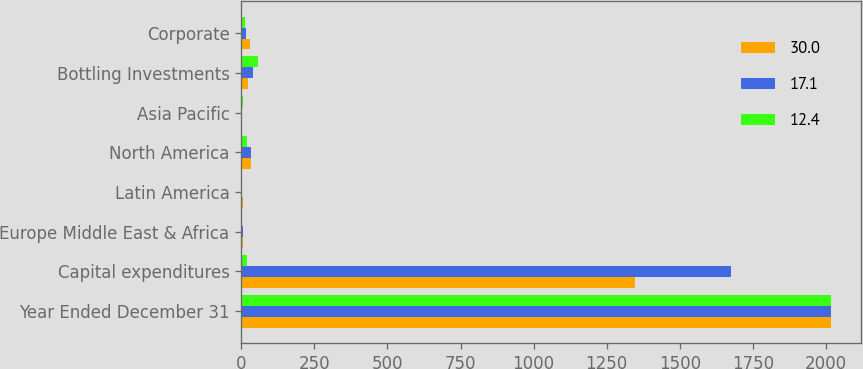Convert chart. <chart><loc_0><loc_0><loc_500><loc_500><stacked_bar_chart><ecel><fcel>Year Ended December 31<fcel>Capital expenditures<fcel>Europe Middle East & Africa<fcel>Latin America<fcel>North America<fcel>Asia Pacific<fcel>Bottling Investments<fcel>Corporate<nl><fcel>30<fcel>2018<fcel>1347<fcel>5.7<fcel>6.7<fcel>31.8<fcel>2.3<fcel>23.5<fcel>30<nl><fcel>17.1<fcel>2017<fcel>1675<fcel>4.8<fcel>3.3<fcel>32.3<fcel>3<fcel>39.5<fcel>17.1<nl><fcel>12.4<fcel>2016<fcel>19.4<fcel>2.7<fcel>2<fcel>19.4<fcel>4.7<fcel>58.8<fcel>12.4<nl></chart> 